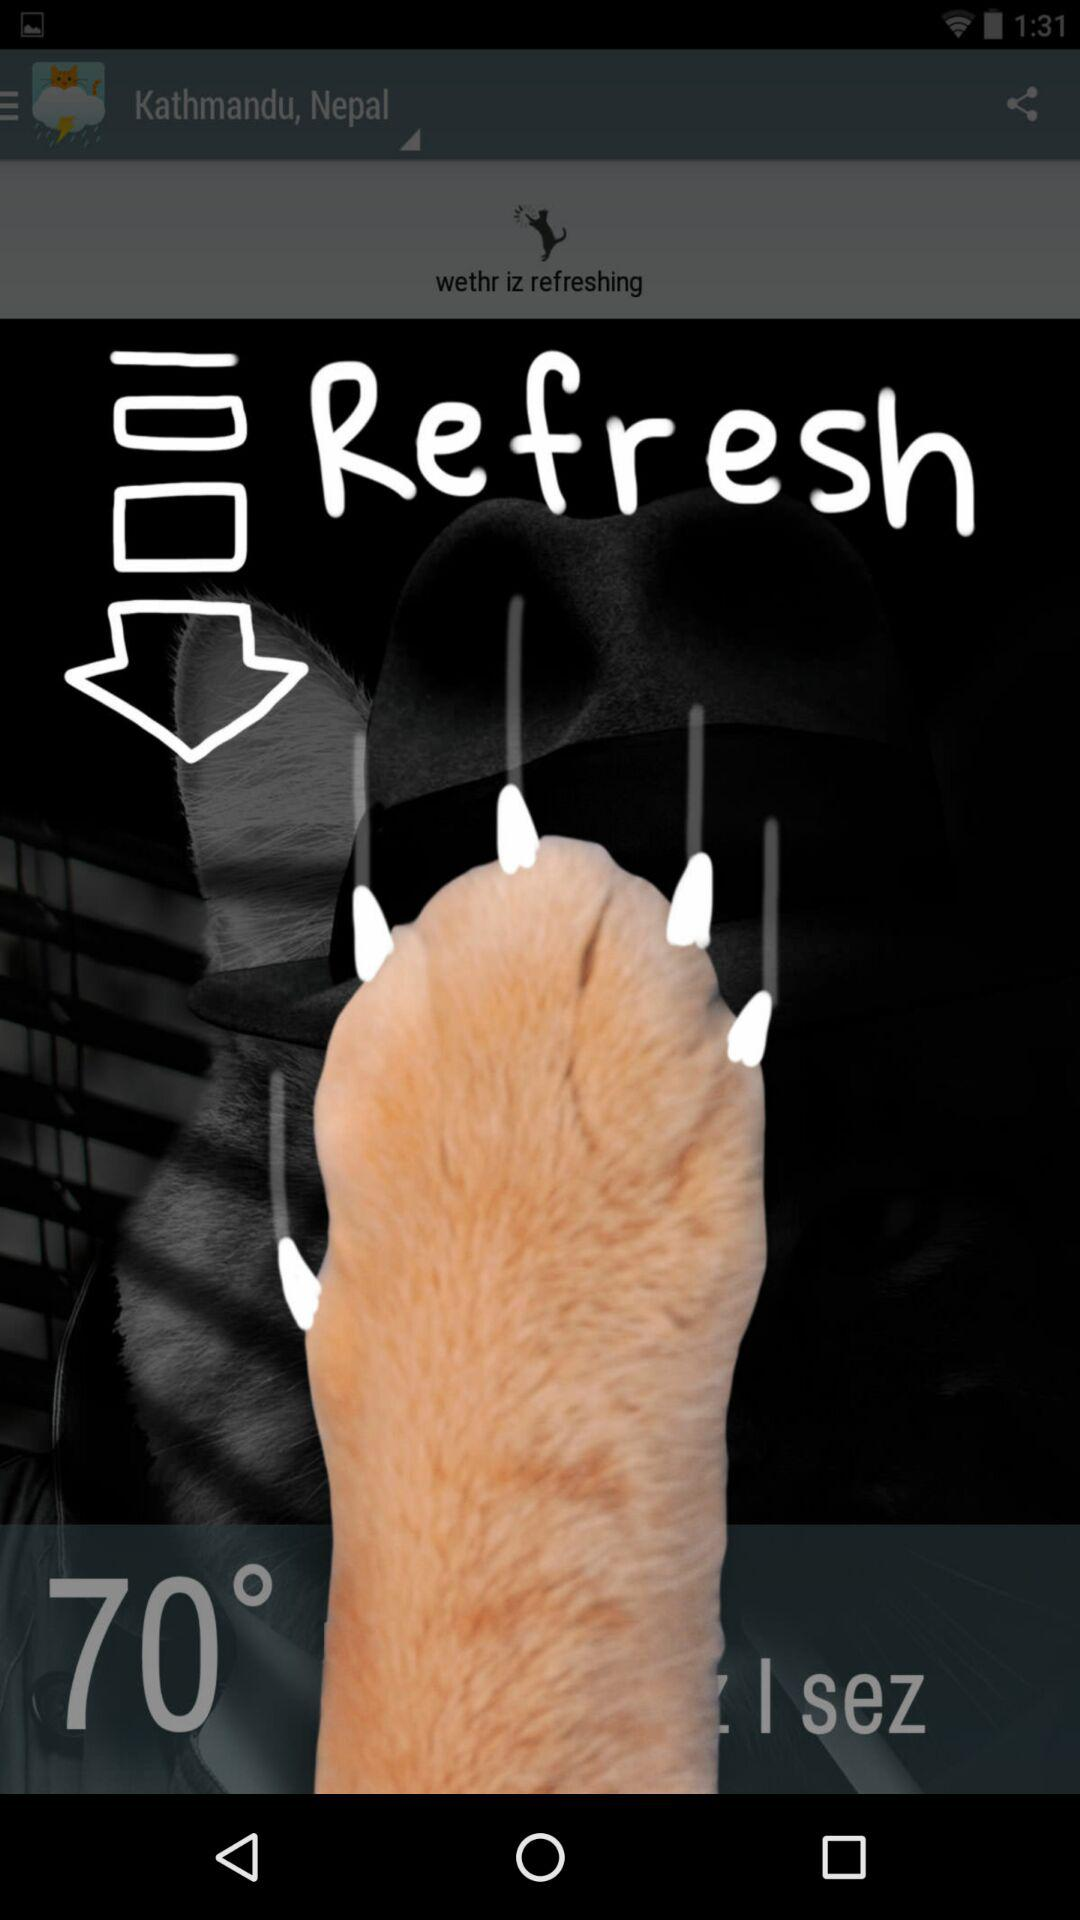What is the given temperature? The given temperature is 70°. 